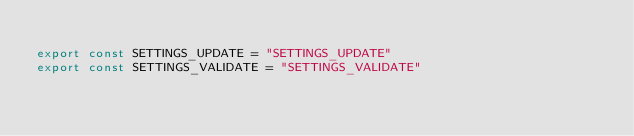<code> <loc_0><loc_0><loc_500><loc_500><_JavaScript_>
export const SETTINGS_UPDATE = "SETTINGS_UPDATE"
export const SETTINGS_VALIDATE = "SETTINGS_VALIDATE"
</code> 